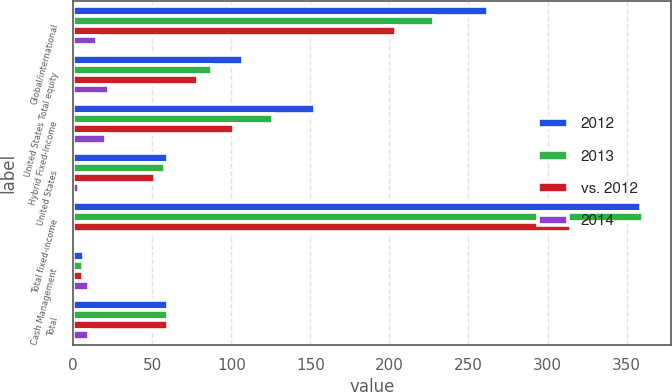<chart> <loc_0><loc_0><loc_500><loc_500><stacked_bar_chart><ecel><fcel>Global/international<fcel>United States Total equity<fcel>Hybrid Fixed-Income<fcel>United States<fcel>Total fixed-income<fcel>Cash Management<fcel>Total<nl><fcel>2012<fcel>262.1<fcel>107.6<fcel>152.7<fcel>60.2<fcel>358.9<fcel>6.6<fcel>60.2<nl><fcel>2013<fcel>228.1<fcel>87.8<fcel>126.2<fcel>57.9<fcel>360.1<fcel>6<fcel>60.2<nl><fcel>vs. 2012<fcel>204.3<fcel>78.7<fcel>101.9<fcel>51.6<fcel>314.5<fcel>6.3<fcel>60.2<nl><fcel>2014<fcel>15<fcel>23<fcel>21<fcel>4<fcel>0<fcel>10<fcel>10<nl></chart> 